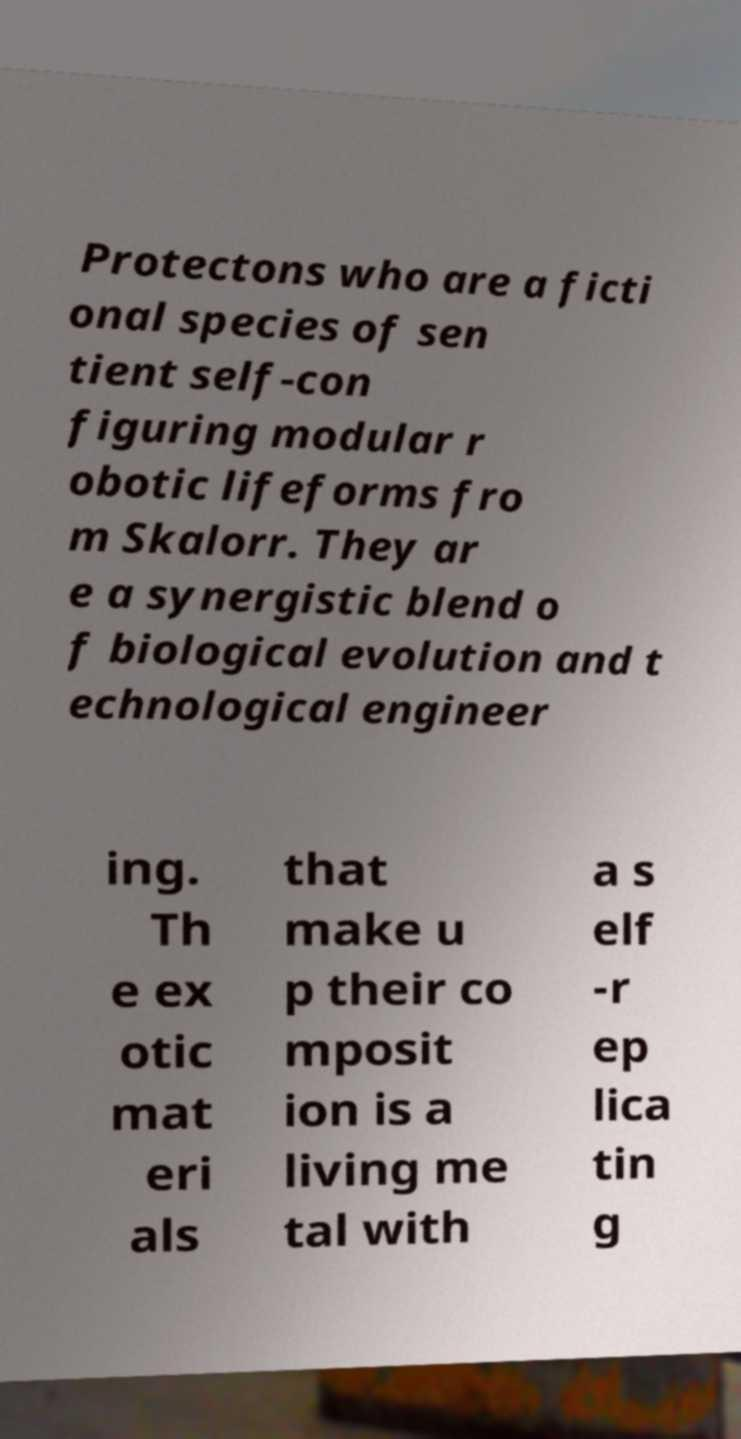I need the written content from this picture converted into text. Can you do that? Protectons who are a ficti onal species of sen tient self-con figuring modular r obotic lifeforms fro m Skalorr. They ar e a synergistic blend o f biological evolution and t echnological engineer ing. Th e ex otic mat eri als that make u p their co mposit ion is a living me tal with a s elf -r ep lica tin g 